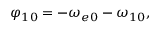<formula> <loc_0><loc_0><loc_500><loc_500>\varphi _ { 1 0 } = - \omega _ { e 0 } - \omega _ { 1 0 } ,</formula> 